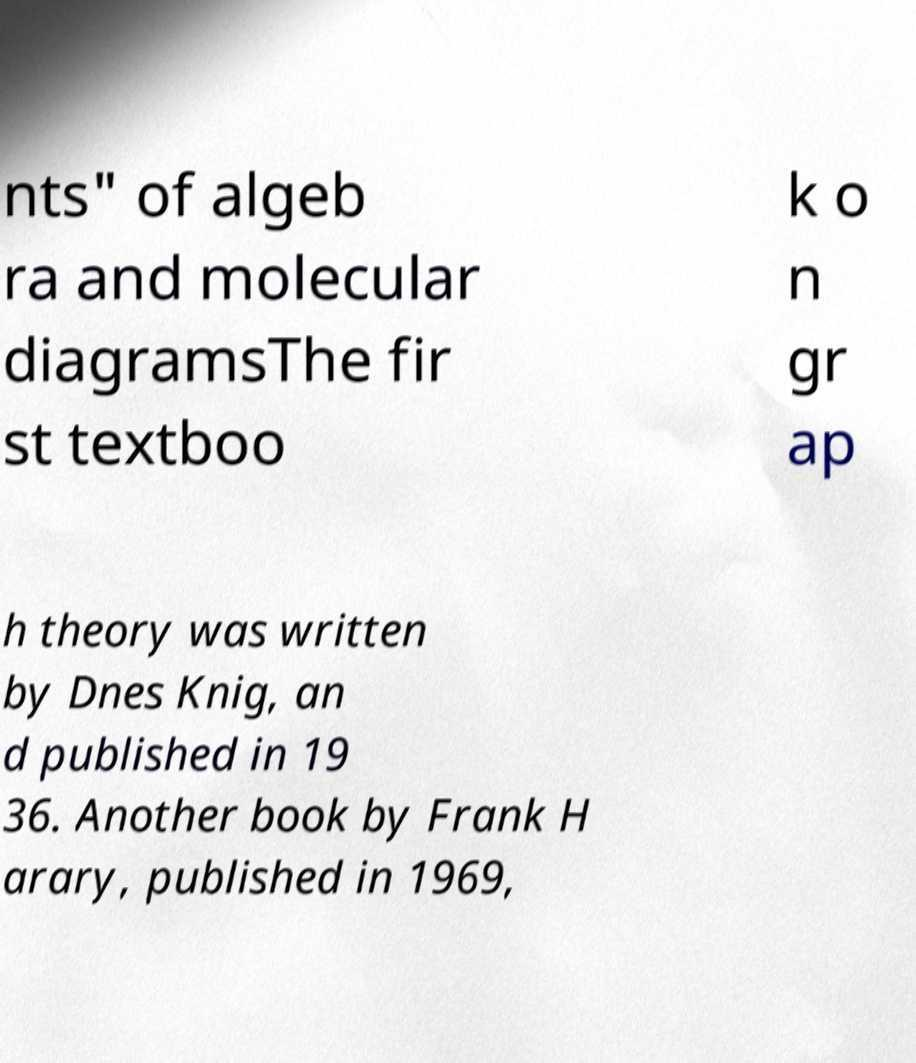What messages or text are displayed in this image? I need them in a readable, typed format. nts" of algeb ra and molecular diagramsThe fir st textboo k o n gr ap h theory was written by Dnes Knig, an d published in 19 36. Another book by Frank H arary, published in 1969, 